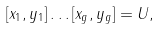<formula> <loc_0><loc_0><loc_500><loc_500>[ x _ { 1 } , y _ { 1 } ] \dots [ x _ { g } , y _ { g } ] = U ,</formula> 